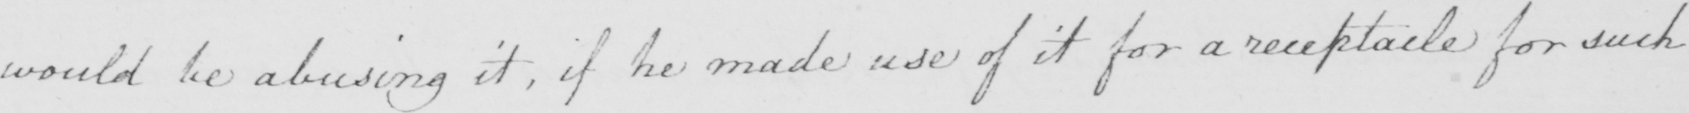Can you tell me what this handwritten text says? would be abusing it , if he made use of it for a receptacle for such 